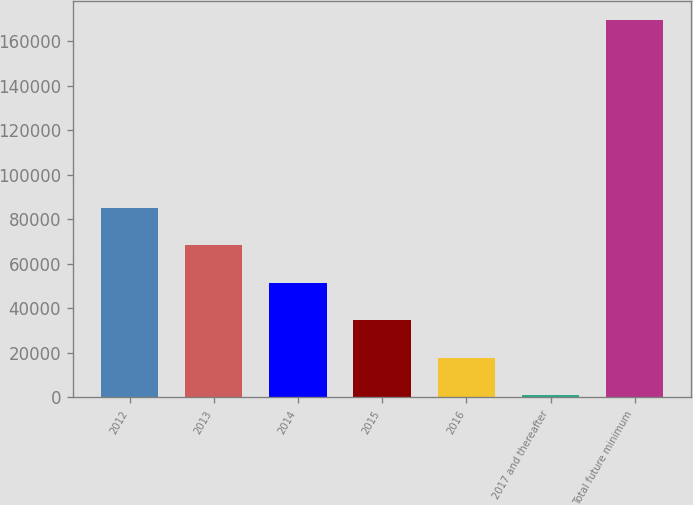Convert chart to OTSL. <chart><loc_0><loc_0><loc_500><loc_500><bar_chart><fcel>2012<fcel>2013<fcel>2014<fcel>2015<fcel>2016<fcel>2017 and thereafter<fcel>Total future minimum<nl><fcel>85240<fcel>68385.2<fcel>51530.4<fcel>34675.6<fcel>17820.8<fcel>966<fcel>169514<nl></chart> 